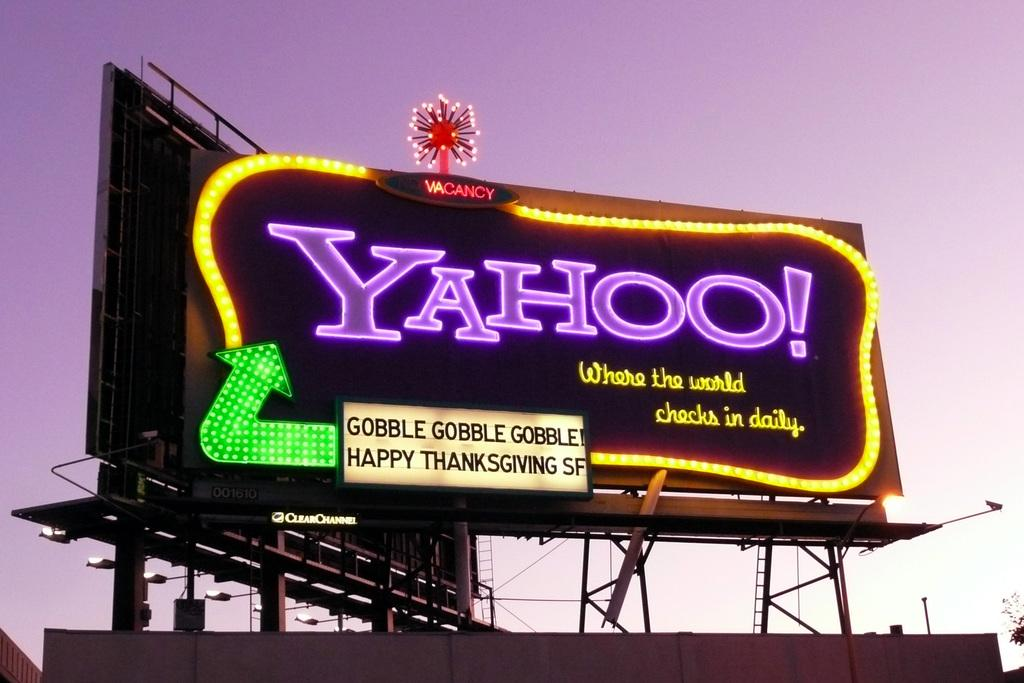<image>
Relay a brief, clear account of the picture shown. A large Yahoo advertisement that reads the world checks in daily. 